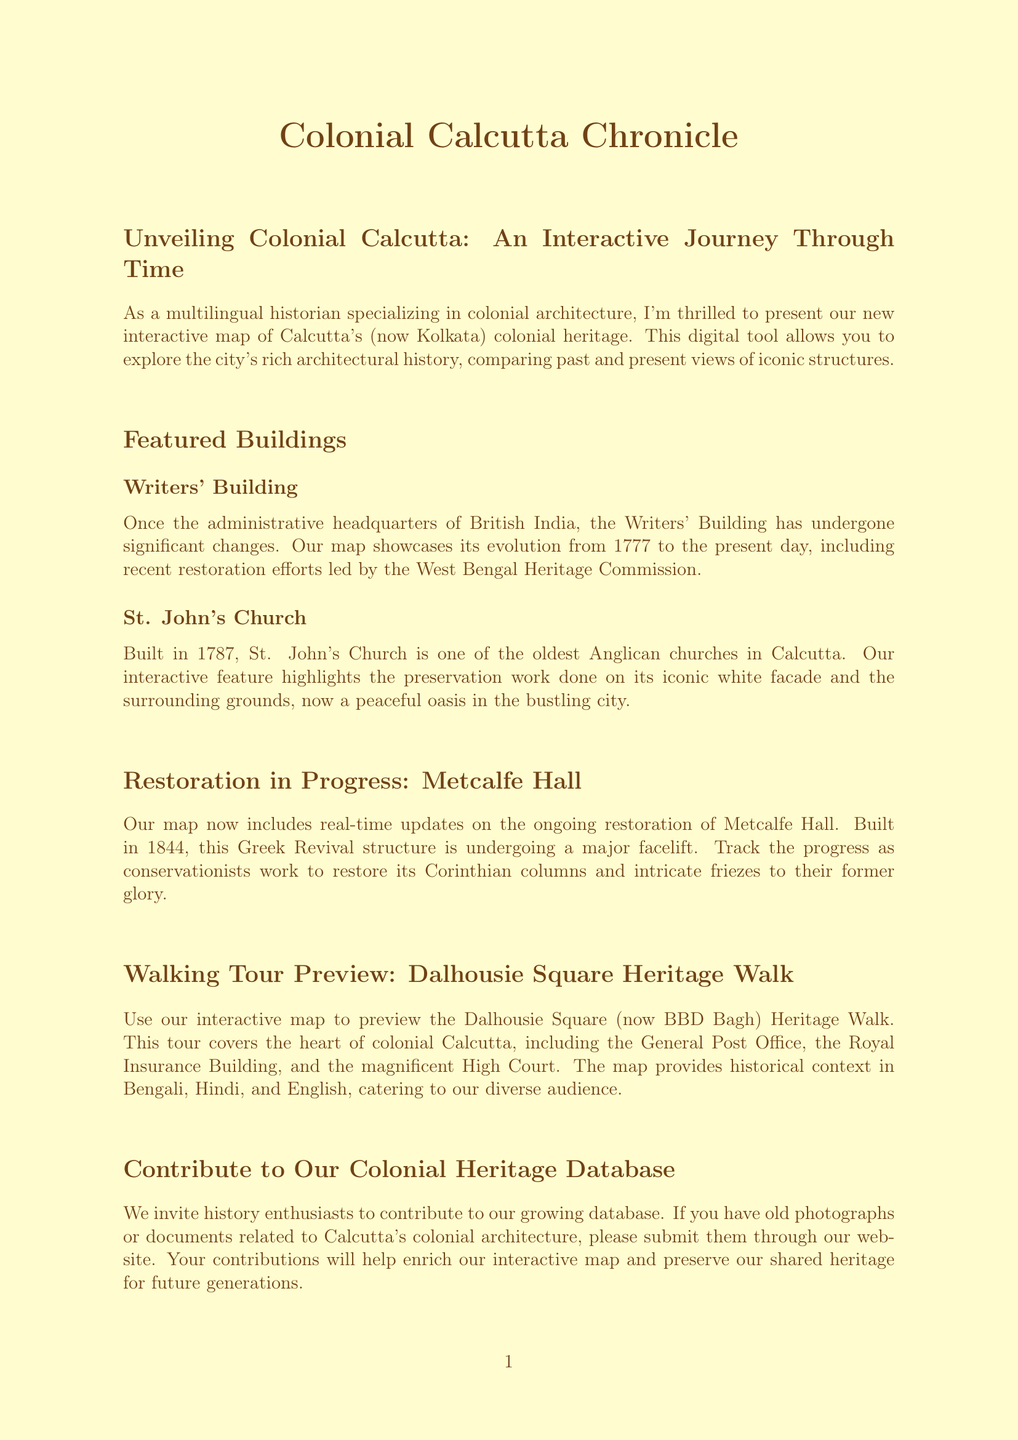What is the title of the newsletter? The title of the newsletter is listed at the top of the document.
Answer: Colonial Calcutta Chronicle How many featured buildings are highlighted in the newsletter? The newsletter lists the number of featured buildings under the relevant section.
Answer: 2 What year was St. John's Church built? The document provides the construction year as part of the building description.
Answer: 1787 What is currently in progress for Metcalfe Hall? The document mentions specific work being done on Metcalfe Hall in the restoration section.
Answer: Restoration Which languages does the Dalhousie Square Heritage Walk provide historical context in? The newsletter describes the languages available in the heritage walk preview section.
Answer: Bengali, Hindi, and English What type of experience is being developed for the interactive map? The newsletter mentions an upcoming feature that will enhance user engagement with the map.
Answer: Augmented Reality Experience Who should history enthusiasts contact to contribute old photographs? The document calls out a specific action for contributions from the community.
Answer: Our website When was the Writers' Building originally constructed? The document includes details about the construction and evolution timeline of the Writers' Building.
Answer: 1777 